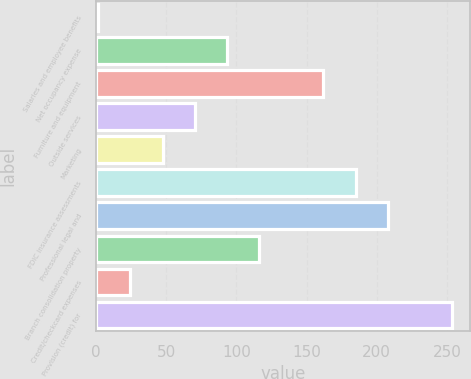Convert chart. <chart><loc_0><loc_0><loc_500><loc_500><bar_chart><fcel>Salaries and employee benefits<fcel>Net occupancy expense<fcel>Furniture and equipment<fcel>Outside services<fcel>Marketing<fcel>FDIC insurance assessments<fcel>Professional legal and<fcel>Branch consolidation property<fcel>Credit/checkcard expenses<fcel>Provision (credit) for<nl><fcel>1.6<fcel>93.28<fcel>162.04<fcel>70.36<fcel>47.44<fcel>184.96<fcel>207.88<fcel>116.2<fcel>24.52<fcel>253.72<nl></chart> 